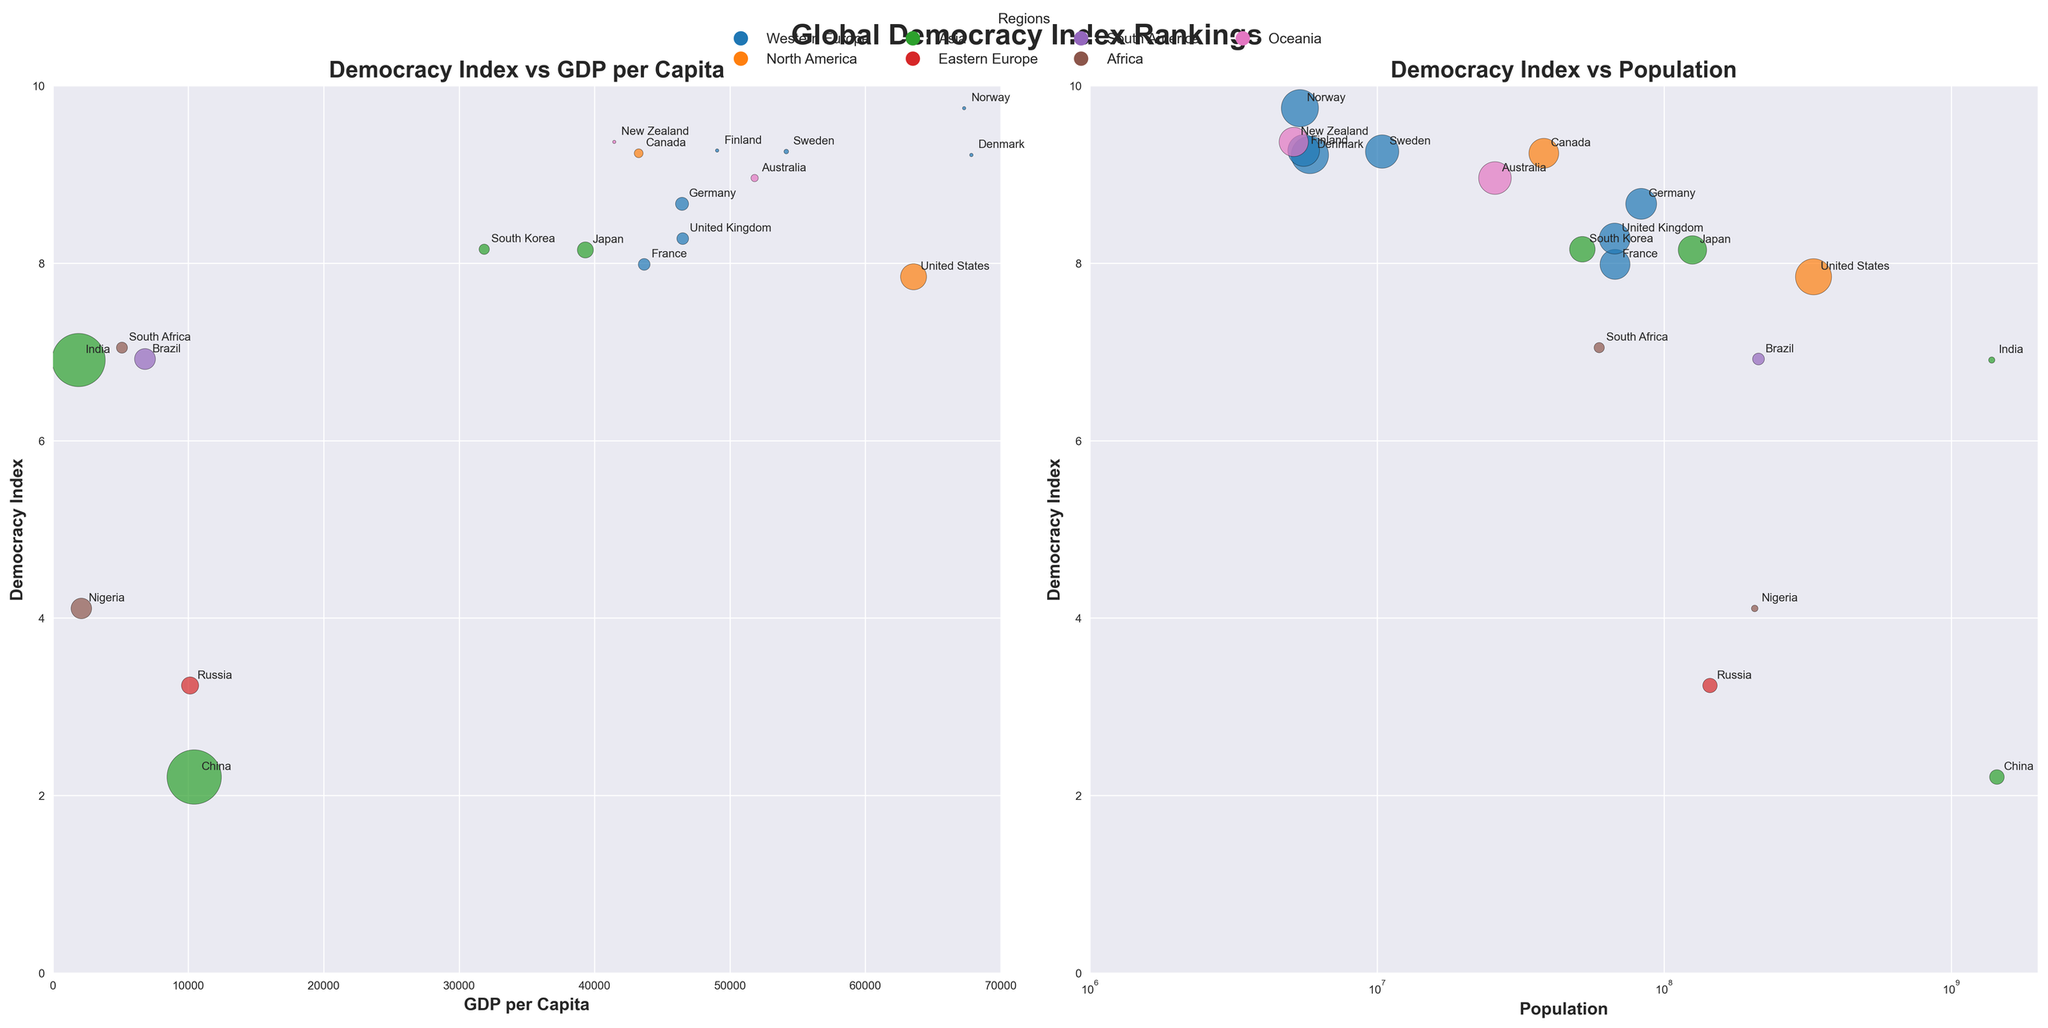What is the title of the subplot displaying GDP per Capita on the x-axis? On the left subplot, the x-axis is labeled as GDP per Capita. The title of this subplot above the plot is "Democracy Index vs GDP per Capita".
Answer: Democracy Index vs GDP per Capita Which country has the highest Democracy Index in the figure? The Democracy Index is highest for Norway as it has a value of 9.75, which is clearly above any other country in the figure.
Answer: Norway What is the Democracy Index of Brazil? By looking for the labeled bubble for Brazil on either subplot, its Democracy Index value is clearly annotated near the bubble. The Democracy Index for Brazil is 6.92.
Answer: 6.92 Which country in Western Europe has the lowest GDP per Capita? In the left subplot, focus on the x-axis (GDP per Capita). Among Western European countries, look for the smallest value which belongs to Germany, France, and the United Kingdom. France has the lowest GDP per Capita among them, which is around 43659.
Answer: France Which region has the most countries with a Democracy Index above 8.0? On both subplots, find the colored bubbles associated with each region. Western Europe has multiple countries (Denmark, Sweden, Norway, Finland, Germany, and the United Kingdom) with a Democracy Index above 8.0.
Answer: Western Europe How does the Democracy Index of India compare to that of South Korea? Compare the annotated values of the Democracy Index for India (6.91) and South Korea (8.16). South Korea’s Democracy Index is higher than India’s.
Answer: South Korea is higher Compare the GDP per Capita of the United States and Canada. On the left subplot, locate the bubbles for both countries and compare their x-axis coordinates. The United States has a GDP per Capita higher (63544) compared to Canada (43258).
Answer: United States Which African country has the highest Democracy Index? By identifying the bubbles representing African countries on either subplot, South Africa has the highest Democracy Index within its region, which is 7.05.
Answer: South Africa What is the population of New Zealand approximately? In the right subplot, look for the New Zealand bubble. Its population is annotated next to the bubble and is approximately 5,122,600 (about 5.1 million).
Answer: 5.1 million Which variable is plotted on the x-axis of the right subplot? The right subplot has "Population" labeled on the x-axis, representing the population size for each country.
Answer: Population 